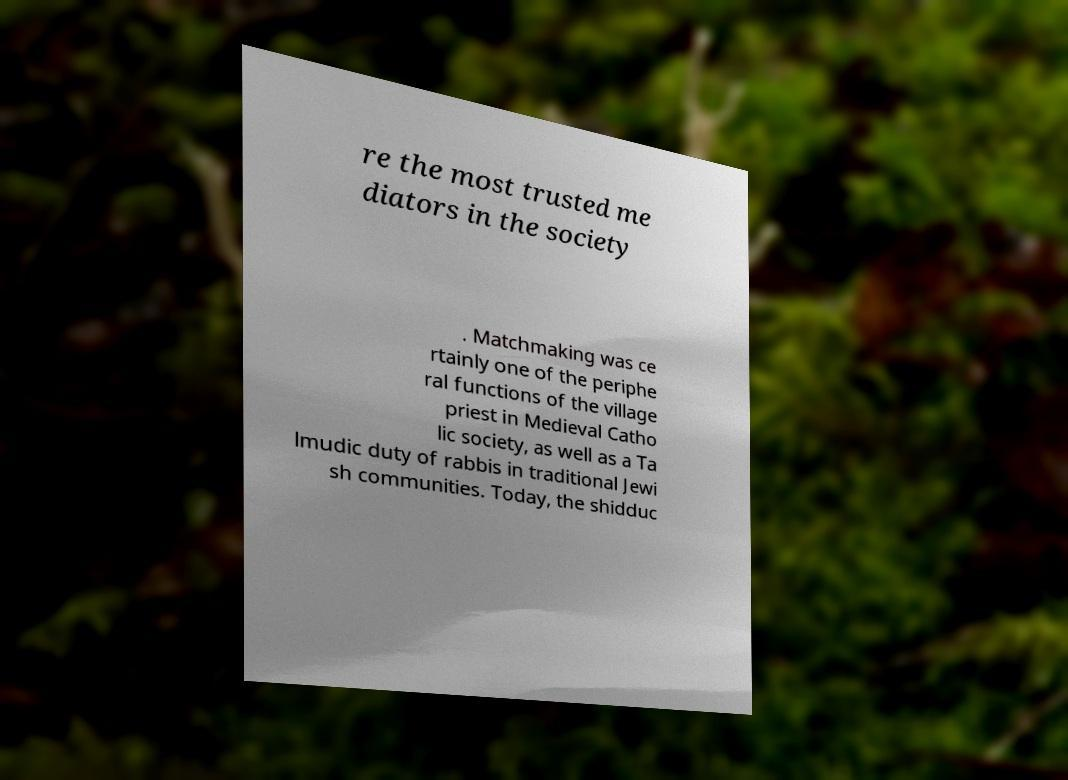Please identify and transcribe the text found in this image. re the most trusted me diators in the society . Matchmaking was ce rtainly one of the periphe ral functions of the village priest in Medieval Catho lic society, as well as a Ta lmudic duty of rabbis in traditional Jewi sh communities. Today, the shidduc 